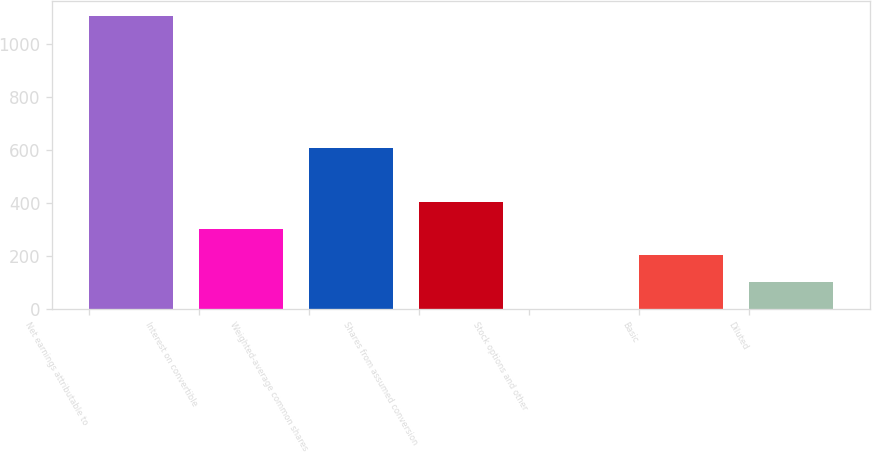<chart> <loc_0><loc_0><loc_500><loc_500><bar_chart><fcel>Net earnings attributable to<fcel>Interest on convertible<fcel>Weighted-average common shares<fcel>Shares from assumed conversion<fcel>Stock options and other<fcel>Basic<fcel>Diluted<nl><fcel>1103.74<fcel>303.82<fcel>606.04<fcel>404.56<fcel>1.6<fcel>203.08<fcel>102.34<nl></chart> 